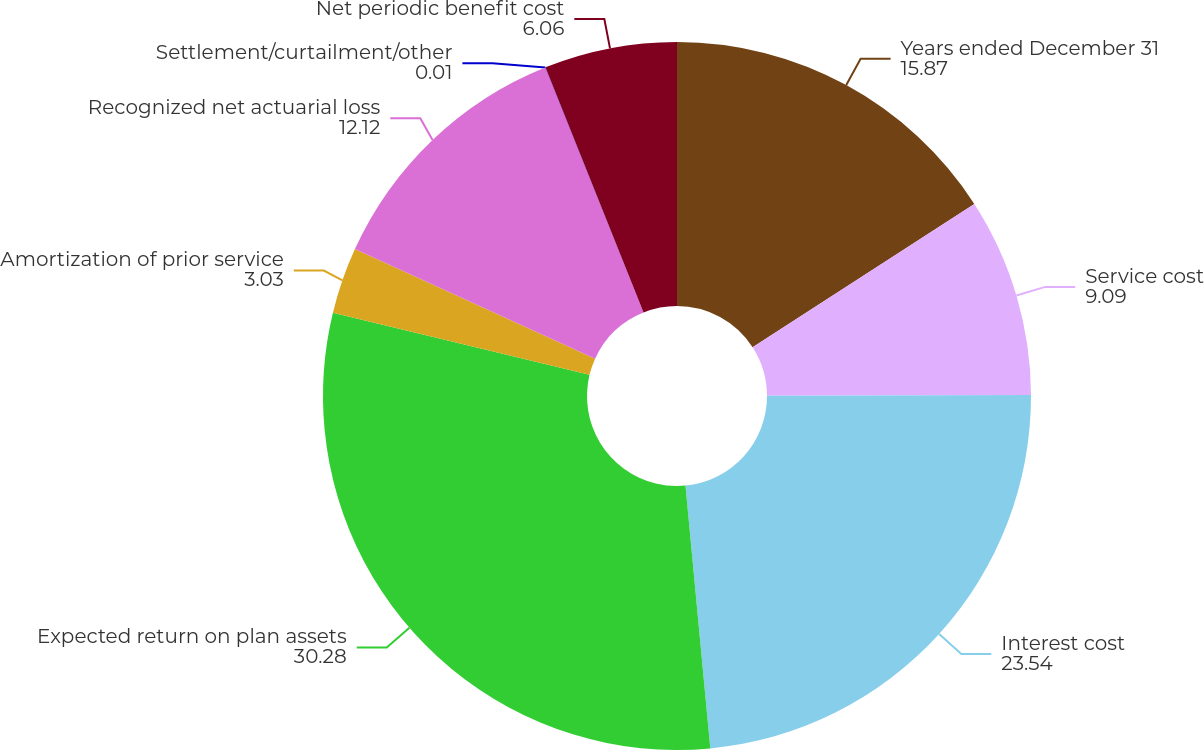Convert chart. <chart><loc_0><loc_0><loc_500><loc_500><pie_chart><fcel>Years ended December 31<fcel>Service cost<fcel>Interest cost<fcel>Expected return on plan assets<fcel>Amortization of prior service<fcel>Recognized net actuarial loss<fcel>Settlement/curtailment/other<fcel>Net periodic benefit cost<nl><fcel>15.87%<fcel>9.09%<fcel>23.54%<fcel>30.28%<fcel>3.03%<fcel>12.12%<fcel>0.01%<fcel>6.06%<nl></chart> 